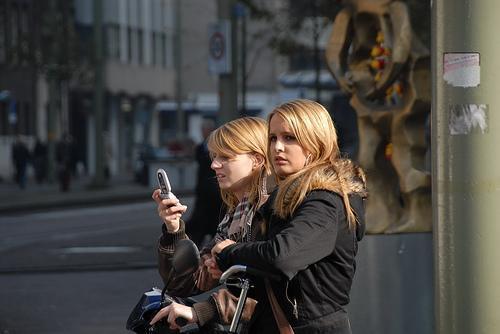The woman on the phone is using what item to move around?
Choose the correct response, then elucidate: 'Answer: answer
Rationale: rationale.'
Options: Skateboard, hoverboard, bicycle, scooter. Answer: scooter.
Rationale: There is a pole under one of the women. 